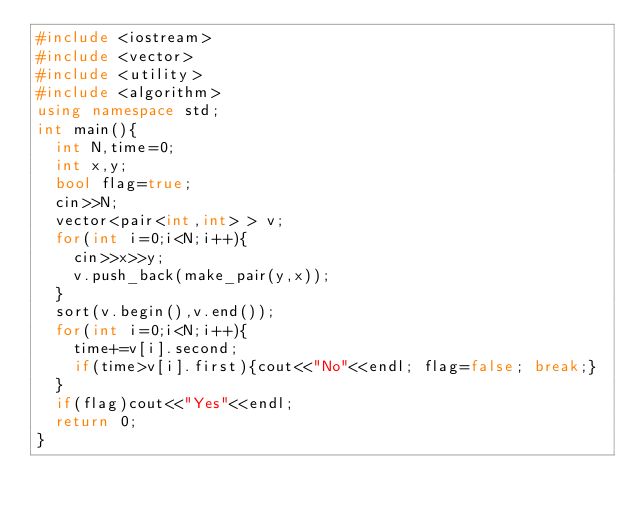Convert code to text. <code><loc_0><loc_0><loc_500><loc_500><_C++_>#include <iostream>
#include <vector>
#include <utility>
#include <algorithm>
using namespace std;
int main(){
  int N,time=0;
  int x,y;
  bool flag=true;
  cin>>N;
  vector<pair<int,int> > v;
  for(int i=0;i<N;i++){
    cin>>x>>y;
    v.push_back(make_pair(y,x));
  }
  sort(v.begin(),v.end());
  for(int i=0;i<N;i++){
    time+=v[i].second;
    if(time>v[i].first){cout<<"No"<<endl; flag=false; break;}
  }
  if(flag)cout<<"Yes"<<endl;
  return 0;
}
</code> 